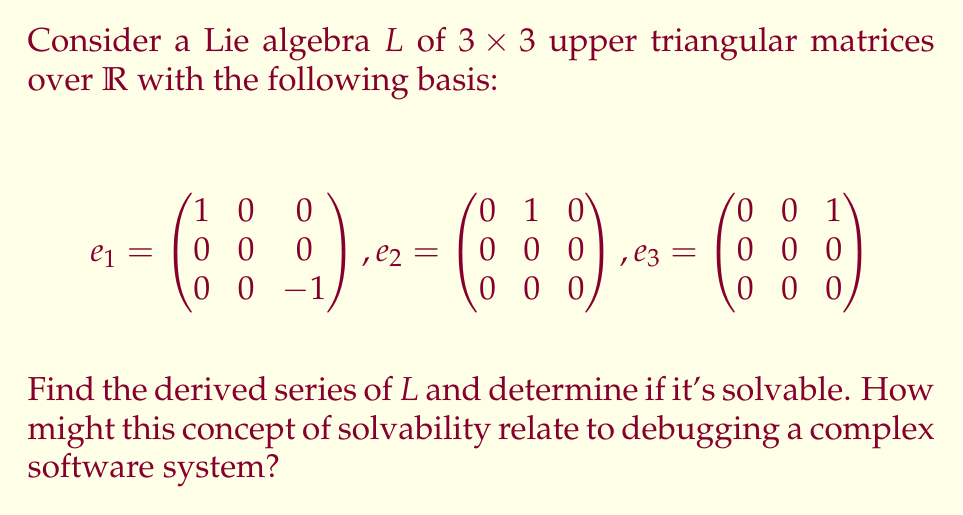Could you help me with this problem? To solve this problem, we'll follow these steps:

1. Calculate the Lie brackets of the basis elements.
2. Find the derived algebra $L^{(1)} = [L,L]$.
3. Continue the process to find $L^{(2)}, L^{(3)},$ etc., until we reach $\{0\}$.
4. Determine if the algebra is solvable.

Step 1: Calculate Lie brackets
The Lie bracket is defined as $[A,B] = AB - BA$ for matrices $A$ and $B$.

$[e_1, e_2] = e_1e_2 - e_2e_1 = e_2$
$[e_1, e_3] = e_1e_3 - e_3e_1 = 2e_3$
$[e_2, e_3] = e_2e_3 - e_3e_2 = 0$

Step 2: Find $L^{(1)} = [L,L]$
$L^{(1)}$ is spanned by $\{e_2, e_3\}$, as these are the only non-zero results from the Lie brackets.

Step 3: Continue the process
$L^{(2)} = [L^{(1)}, L^{(1)}] = [\text{span}\{e_2, e_3\}, \text{span}\{e_2, e_3\}] = \{0\}$

The process terminates here as we've reached the zero subalgebra.

Step 4: Determine solvability
The derived series of $L$ is:
$L \supset L^{(1)} \supset L^{(2)} = \{0\}$

Since the derived series terminates at $\{0\}$ in a finite number of steps, $L$ is solvable.

Relation to debugging complex software systems:
The concept of solvability in Lie algebras can be analogous to the process of debugging complex software systems. Just as we decompose a Lie algebra into simpler subalgebras through the derived series, in debugging, we often break down complex systems into smaller, more manageable components. The termination of the derived series at $\{0\}$ is similar to resolving all bugs in a system, where each step in debugging simplifies the problem until no issues remain.
Answer: The derived series of $L$ is:
$L \supset L^{(1)} = \text{span}\{e_2, e_3\} \supset L^{(2)} = \{0\}$

$L$ is solvable since its derived series terminates at $\{0\}$ in a finite number of steps. 